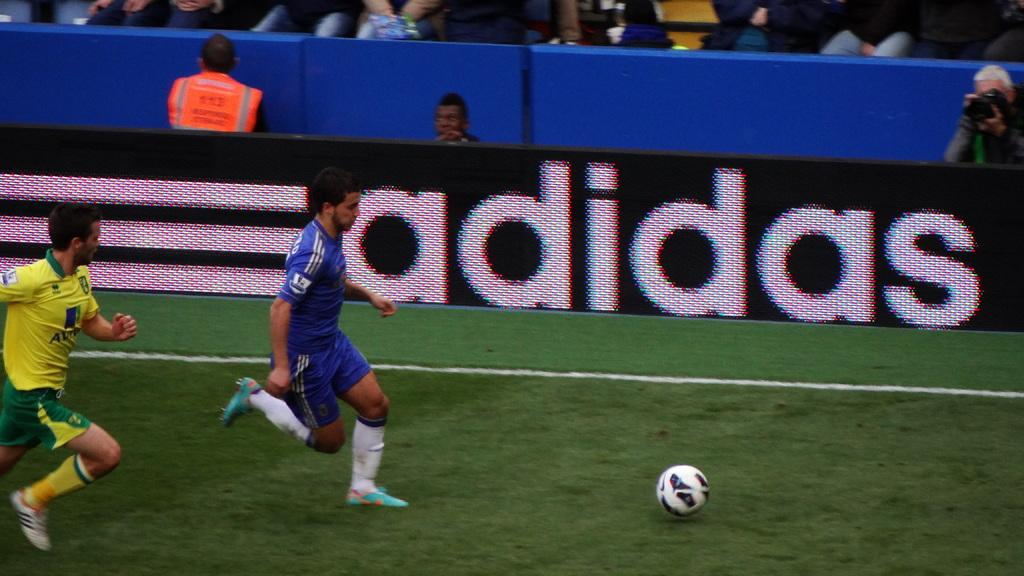<image>
Create a compact narrative representing the image presented. Two soccer players from opposing teams chase a soccer ball on a stadium field while the spectators look on and an adidas advertising signboard is boldly displayed in the arena. 